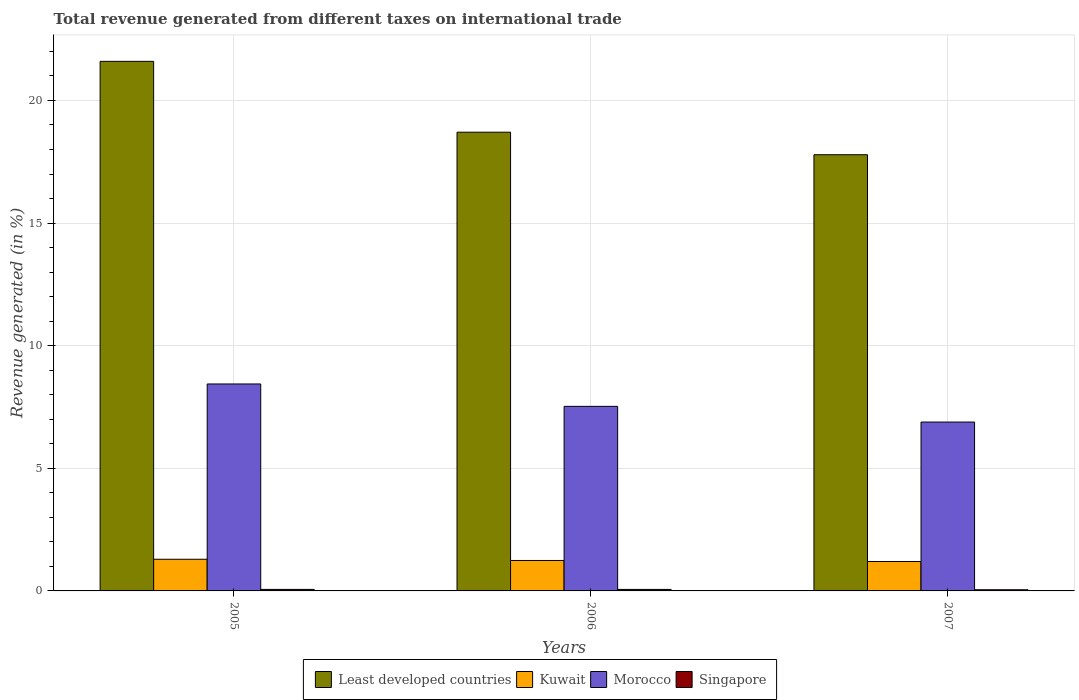How many different coloured bars are there?
Your answer should be very brief. 4. How many groups of bars are there?
Offer a terse response. 3. Are the number of bars per tick equal to the number of legend labels?
Keep it short and to the point. Yes. Are the number of bars on each tick of the X-axis equal?
Your answer should be very brief. Yes. How many bars are there on the 1st tick from the left?
Give a very brief answer. 4. In how many cases, is the number of bars for a given year not equal to the number of legend labels?
Ensure brevity in your answer.  0. What is the total revenue generated in Least developed countries in 2007?
Make the answer very short. 17.79. Across all years, what is the maximum total revenue generated in Kuwait?
Make the answer very short. 1.29. Across all years, what is the minimum total revenue generated in Kuwait?
Your response must be concise. 1.2. What is the total total revenue generated in Kuwait in the graph?
Offer a very short reply. 3.73. What is the difference between the total revenue generated in Least developed countries in 2005 and that in 2007?
Your answer should be very brief. 3.81. What is the difference between the total revenue generated in Least developed countries in 2007 and the total revenue generated in Morocco in 2005?
Give a very brief answer. 9.35. What is the average total revenue generated in Least developed countries per year?
Provide a short and direct response. 19.36. In the year 2005, what is the difference between the total revenue generated in Least developed countries and total revenue generated in Singapore?
Your response must be concise. 21.53. What is the ratio of the total revenue generated in Singapore in 2005 to that in 2006?
Make the answer very short. 1.01. Is the total revenue generated in Singapore in 2005 less than that in 2007?
Offer a very short reply. No. Is the difference between the total revenue generated in Least developed countries in 2005 and 2007 greater than the difference between the total revenue generated in Singapore in 2005 and 2007?
Provide a succinct answer. Yes. What is the difference between the highest and the second highest total revenue generated in Least developed countries?
Provide a short and direct response. 2.89. What is the difference between the highest and the lowest total revenue generated in Singapore?
Keep it short and to the point. 0.01. In how many years, is the total revenue generated in Morocco greater than the average total revenue generated in Morocco taken over all years?
Give a very brief answer. 1. Is it the case that in every year, the sum of the total revenue generated in Kuwait and total revenue generated in Singapore is greater than the sum of total revenue generated in Morocco and total revenue generated in Least developed countries?
Offer a very short reply. Yes. What does the 3rd bar from the left in 2005 represents?
Ensure brevity in your answer.  Morocco. What does the 2nd bar from the right in 2007 represents?
Ensure brevity in your answer.  Morocco. How many years are there in the graph?
Your response must be concise. 3. Are the values on the major ticks of Y-axis written in scientific E-notation?
Your response must be concise. No. Does the graph contain any zero values?
Offer a very short reply. No. Where does the legend appear in the graph?
Your answer should be very brief. Bottom center. How many legend labels are there?
Your answer should be very brief. 4. What is the title of the graph?
Offer a very short reply. Total revenue generated from different taxes on international trade. What is the label or title of the Y-axis?
Provide a succinct answer. Revenue generated (in %). What is the Revenue generated (in %) in Least developed countries in 2005?
Ensure brevity in your answer.  21.59. What is the Revenue generated (in %) of Kuwait in 2005?
Ensure brevity in your answer.  1.29. What is the Revenue generated (in %) in Morocco in 2005?
Ensure brevity in your answer.  8.44. What is the Revenue generated (in %) in Singapore in 2005?
Your response must be concise. 0.06. What is the Revenue generated (in %) in Least developed countries in 2006?
Offer a very short reply. 18.71. What is the Revenue generated (in %) of Kuwait in 2006?
Provide a succinct answer. 1.24. What is the Revenue generated (in %) in Morocco in 2006?
Ensure brevity in your answer.  7.53. What is the Revenue generated (in %) of Singapore in 2006?
Your answer should be compact. 0.06. What is the Revenue generated (in %) in Least developed countries in 2007?
Your answer should be very brief. 17.79. What is the Revenue generated (in %) of Kuwait in 2007?
Give a very brief answer. 1.2. What is the Revenue generated (in %) in Morocco in 2007?
Your response must be concise. 6.89. What is the Revenue generated (in %) in Singapore in 2007?
Give a very brief answer. 0.05. Across all years, what is the maximum Revenue generated (in %) in Least developed countries?
Keep it short and to the point. 21.59. Across all years, what is the maximum Revenue generated (in %) of Kuwait?
Give a very brief answer. 1.29. Across all years, what is the maximum Revenue generated (in %) of Morocco?
Your answer should be compact. 8.44. Across all years, what is the maximum Revenue generated (in %) in Singapore?
Keep it short and to the point. 0.06. Across all years, what is the minimum Revenue generated (in %) in Least developed countries?
Provide a succinct answer. 17.79. Across all years, what is the minimum Revenue generated (in %) of Kuwait?
Give a very brief answer. 1.2. Across all years, what is the minimum Revenue generated (in %) in Morocco?
Your answer should be compact. 6.89. Across all years, what is the minimum Revenue generated (in %) of Singapore?
Make the answer very short. 0.05. What is the total Revenue generated (in %) of Least developed countries in the graph?
Provide a succinct answer. 58.09. What is the total Revenue generated (in %) of Kuwait in the graph?
Offer a very short reply. 3.73. What is the total Revenue generated (in %) in Morocco in the graph?
Offer a terse response. 22.85. What is the total Revenue generated (in %) in Singapore in the graph?
Provide a short and direct response. 0.17. What is the difference between the Revenue generated (in %) in Least developed countries in 2005 and that in 2006?
Offer a terse response. 2.89. What is the difference between the Revenue generated (in %) of Kuwait in 2005 and that in 2006?
Give a very brief answer. 0.05. What is the difference between the Revenue generated (in %) of Morocco in 2005 and that in 2006?
Provide a succinct answer. 0.91. What is the difference between the Revenue generated (in %) in Singapore in 2005 and that in 2006?
Your answer should be compact. 0. What is the difference between the Revenue generated (in %) in Least developed countries in 2005 and that in 2007?
Give a very brief answer. 3.81. What is the difference between the Revenue generated (in %) of Kuwait in 2005 and that in 2007?
Make the answer very short. 0.09. What is the difference between the Revenue generated (in %) of Morocco in 2005 and that in 2007?
Make the answer very short. 1.55. What is the difference between the Revenue generated (in %) of Singapore in 2005 and that in 2007?
Offer a very short reply. 0.01. What is the difference between the Revenue generated (in %) of Least developed countries in 2006 and that in 2007?
Keep it short and to the point. 0.92. What is the difference between the Revenue generated (in %) in Kuwait in 2006 and that in 2007?
Make the answer very short. 0.04. What is the difference between the Revenue generated (in %) of Morocco in 2006 and that in 2007?
Your answer should be compact. 0.64. What is the difference between the Revenue generated (in %) in Singapore in 2006 and that in 2007?
Keep it short and to the point. 0.01. What is the difference between the Revenue generated (in %) in Least developed countries in 2005 and the Revenue generated (in %) in Kuwait in 2006?
Keep it short and to the point. 20.35. What is the difference between the Revenue generated (in %) in Least developed countries in 2005 and the Revenue generated (in %) in Morocco in 2006?
Offer a very short reply. 14.07. What is the difference between the Revenue generated (in %) in Least developed countries in 2005 and the Revenue generated (in %) in Singapore in 2006?
Make the answer very short. 21.53. What is the difference between the Revenue generated (in %) in Kuwait in 2005 and the Revenue generated (in %) in Morocco in 2006?
Make the answer very short. -6.24. What is the difference between the Revenue generated (in %) of Kuwait in 2005 and the Revenue generated (in %) of Singapore in 2006?
Offer a very short reply. 1.23. What is the difference between the Revenue generated (in %) of Morocco in 2005 and the Revenue generated (in %) of Singapore in 2006?
Your response must be concise. 8.38. What is the difference between the Revenue generated (in %) of Least developed countries in 2005 and the Revenue generated (in %) of Kuwait in 2007?
Offer a terse response. 20.39. What is the difference between the Revenue generated (in %) of Least developed countries in 2005 and the Revenue generated (in %) of Morocco in 2007?
Ensure brevity in your answer.  14.71. What is the difference between the Revenue generated (in %) of Least developed countries in 2005 and the Revenue generated (in %) of Singapore in 2007?
Provide a succinct answer. 21.55. What is the difference between the Revenue generated (in %) of Kuwait in 2005 and the Revenue generated (in %) of Morocco in 2007?
Ensure brevity in your answer.  -5.6. What is the difference between the Revenue generated (in %) in Kuwait in 2005 and the Revenue generated (in %) in Singapore in 2007?
Your answer should be very brief. 1.24. What is the difference between the Revenue generated (in %) in Morocco in 2005 and the Revenue generated (in %) in Singapore in 2007?
Offer a very short reply. 8.39. What is the difference between the Revenue generated (in %) in Least developed countries in 2006 and the Revenue generated (in %) in Kuwait in 2007?
Offer a terse response. 17.51. What is the difference between the Revenue generated (in %) in Least developed countries in 2006 and the Revenue generated (in %) in Morocco in 2007?
Your answer should be compact. 11.82. What is the difference between the Revenue generated (in %) in Least developed countries in 2006 and the Revenue generated (in %) in Singapore in 2007?
Provide a succinct answer. 18.66. What is the difference between the Revenue generated (in %) of Kuwait in 2006 and the Revenue generated (in %) of Morocco in 2007?
Give a very brief answer. -5.64. What is the difference between the Revenue generated (in %) of Kuwait in 2006 and the Revenue generated (in %) of Singapore in 2007?
Offer a terse response. 1.19. What is the difference between the Revenue generated (in %) of Morocco in 2006 and the Revenue generated (in %) of Singapore in 2007?
Your answer should be very brief. 7.48. What is the average Revenue generated (in %) in Least developed countries per year?
Make the answer very short. 19.36. What is the average Revenue generated (in %) of Kuwait per year?
Give a very brief answer. 1.24. What is the average Revenue generated (in %) in Morocco per year?
Provide a short and direct response. 7.62. What is the average Revenue generated (in %) of Singapore per year?
Ensure brevity in your answer.  0.06. In the year 2005, what is the difference between the Revenue generated (in %) in Least developed countries and Revenue generated (in %) in Kuwait?
Your response must be concise. 20.3. In the year 2005, what is the difference between the Revenue generated (in %) of Least developed countries and Revenue generated (in %) of Morocco?
Keep it short and to the point. 13.16. In the year 2005, what is the difference between the Revenue generated (in %) of Least developed countries and Revenue generated (in %) of Singapore?
Your answer should be very brief. 21.53. In the year 2005, what is the difference between the Revenue generated (in %) in Kuwait and Revenue generated (in %) in Morocco?
Offer a very short reply. -7.15. In the year 2005, what is the difference between the Revenue generated (in %) of Kuwait and Revenue generated (in %) of Singapore?
Offer a terse response. 1.23. In the year 2005, what is the difference between the Revenue generated (in %) of Morocco and Revenue generated (in %) of Singapore?
Offer a very short reply. 8.38. In the year 2006, what is the difference between the Revenue generated (in %) in Least developed countries and Revenue generated (in %) in Kuwait?
Provide a succinct answer. 17.46. In the year 2006, what is the difference between the Revenue generated (in %) in Least developed countries and Revenue generated (in %) in Morocco?
Give a very brief answer. 11.18. In the year 2006, what is the difference between the Revenue generated (in %) of Least developed countries and Revenue generated (in %) of Singapore?
Provide a succinct answer. 18.64. In the year 2006, what is the difference between the Revenue generated (in %) in Kuwait and Revenue generated (in %) in Morocco?
Provide a succinct answer. -6.29. In the year 2006, what is the difference between the Revenue generated (in %) in Kuwait and Revenue generated (in %) in Singapore?
Your response must be concise. 1.18. In the year 2006, what is the difference between the Revenue generated (in %) in Morocco and Revenue generated (in %) in Singapore?
Offer a very short reply. 7.46. In the year 2007, what is the difference between the Revenue generated (in %) of Least developed countries and Revenue generated (in %) of Kuwait?
Your answer should be compact. 16.59. In the year 2007, what is the difference between the Revenue generated (in %) in Least developed countries and Revenue generated (in %) in Morocco?
Make the answer very short. 10.9. In the year 2007, what is the difference between the Revenue generated (in %) in Least developed countries and Revenue generated (in %) in Singapore?
Ensure brevity in your answer.  17.74. In the year 2007, what is the difference between the Revenue generated (in %) in Kuwait and Revenue generated (in %) in Morocco?
Offer a very short reply. -5.69. In the year 2007, what is the difference between the Revenue generated (in %) of Kuwait and Revenue generated (in %) of Singapore?
Ensure brevity in your answer.  1.15. In the year 2007, what is the difference between the Revenue generated (in %) of Morocco and Revenue generated (in %) of Singapore?
Provide a short and direct response. 6.84. What is the ratio of the Revenue generated (in %) of Least developed countries in 2005 to that in 2006?
Give a very brief answer. 1.15. What is the ratio of the Revenue generated (in %) in Kuwait in 2005 to that in 2006?
Offer a very short reply. 1.04. What is the ratio of the Revenue generated (in %) of Morocco in 2005 to that in 2006?
Your answer should be very brief. 1.12. What is the ratio of the Revenue generated (in %) in Singapore in 2005 to that in 2006?
Keep it short and to the point. 1.01. What is the ratio of the Revenue generated (in %) in Least developed countries in 2005 to that in 2007?
Your answer should be very brief. 1.21. What is the ratio of the Revenue generated (in %) of Kuwait in 2005 to that in 2007?
Offer a terse response. 1.08. What is the ratio of the Revenue generated (in %) in Morocco in 2005 to that in 2007?
Ensure brevity in your answer.  1.23. What is the ratio of the Revenue generated (in %) in Singapore in 2005 to that in 2007?
Provide a succinct answer. 1.3. What is the ratio of the Revenue generated (in %) of Least developed countries in 2006 to that in 2007?
Your answer should be compact. 1.05. What is the ratio of the Revenue generated (in %) of Kuwait in 2006 to that in 2007?
Give a very brief answer. 1.03. What is the ratio of the Revenue generated (in %) of Morocco in 2006 to that in 2007?
Your answer should be compact. 1.09. What is the ratio of the Revenue generated (in %) of Singapore in 2006 to that in 2007?
Provide a succinct answer. 1.29. What is the difference between the highest and the second highest Revenue generated (in %) of Least developed countries?
Your answer should be very brief. 2.89. What is the difference between the highest and the second highest Revenue generated (in %) of Kuwait?
Your answer should be compact. 0.05. What is the difference between the highest and the second highest Revenue generated (in %) in Morocco?
Your answer should be compact. 0.91. What is the difference between the highest and the second highest Revenue generated (in %) in Singapore?
Give a very brief answer. 0. What is the difference between the highest and the lowest Revenue generated (in %) of Least developed countries?
Offer a very short reply. 3.81. What is the difference between the highest and the lowest Revenue generated (in %) of Kuwait?
Provide a succinct answer. 0.09. What is the difference between the highest and the lowest Revenue generated (in %) in Morocco?
Provide a succinct answer. 1.55. What is the difference between the highest and the lowest Revenue generated (in %) in Singapore?
Provide a short and direct response. 0.01. 